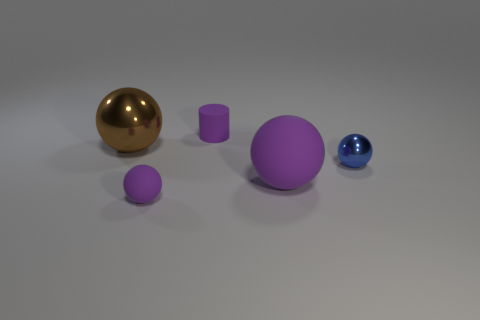Add 2 metallic spheres. How many objects exist? 7 Subtract all big purple rubber spheres. How many spheres are left? 3 Subtract all balls. How many objects are left? 1 Subtract all red cylinders. How many purple spheres are left? 2 Subtract all blue spheres. How many spheres are left? 3 Subtract all tiny objects. Subtract all tiny blue balls. How many objects are left? 1 Add 1 purple things. How many purple things are left? 4 Add 3 tiny green cylinders. How many tiny green cylinders exist? 3 Subtract 0 gray cylinders. How many objects are left? 5 Subtract all brown cylinders. Subtract all gray blocks. How many cylinders are left? 1 